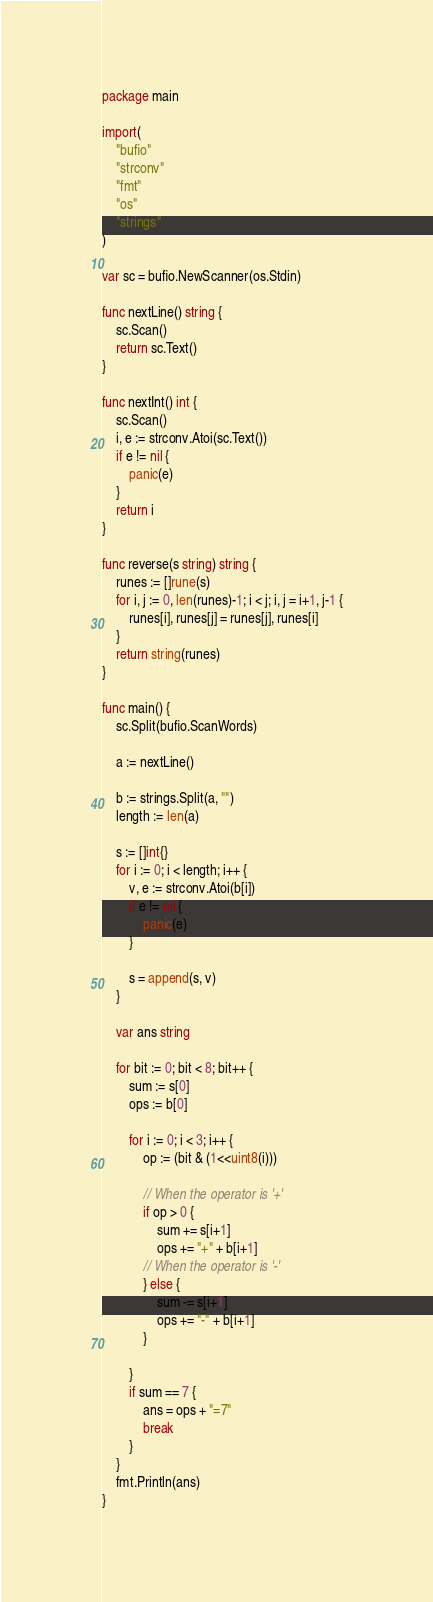Convert code to text. <code><loc_0><loc_0><loc_500><loc_500><_Go_>package main

import(
	"bufio"
	"strconv"
	"fmt"
	"os"
	"strings"
)

var sc = bufio.NewScanner(os.Stdin)

func nextLine() string {
	sc.Scan()
	return sc.Text()
}

func nextInt() int {
	sc.Scan()
	i, e := strconv.Atoi(sc.Text())
	if e != nil {
		panic(e)
	}
	return i
}

func reverse(s string) string {
	runes := []rune(s)
	for i, j := 0, len(runes)-1; i < j; i, j = i+1, j-1 {
		runes[i], runes[j] = runes[j], runes[i]
	}
	return string(runes)
}

func main() {
	sc.Split(bufio.ScanWords)

	a := nextLine()

	b := strings.Split(a, "")
	length := len(a)
	
	s := []int{}
	for i := 0; i < length; i++ {
		v, e := strconv.Atoi(b[i])
		if e != nil {
			panic(e)
		}

		s = append(s, v)
	}

	var ans string

	for bit := 0; bit < 8; bit++ {
		sum := s[0]
		ops := b[0]

		for i := 0; i < 3; i++ {
			op := (bit & (1<<uint8(i)))

			// When the operator is '+'
			if op > 0 {
				sum += s[i+1]
				ops += "+" + b[i+1]
			// When the operator is '-'
			} else {
				sum -= s[i+1]
				ops += "-" + b[i+1]
			}
	
		}
		if sum == 7 {
			ans = ops + "=7"
			break
		}
	}
	fmt.Println(ans)
}
</code> 